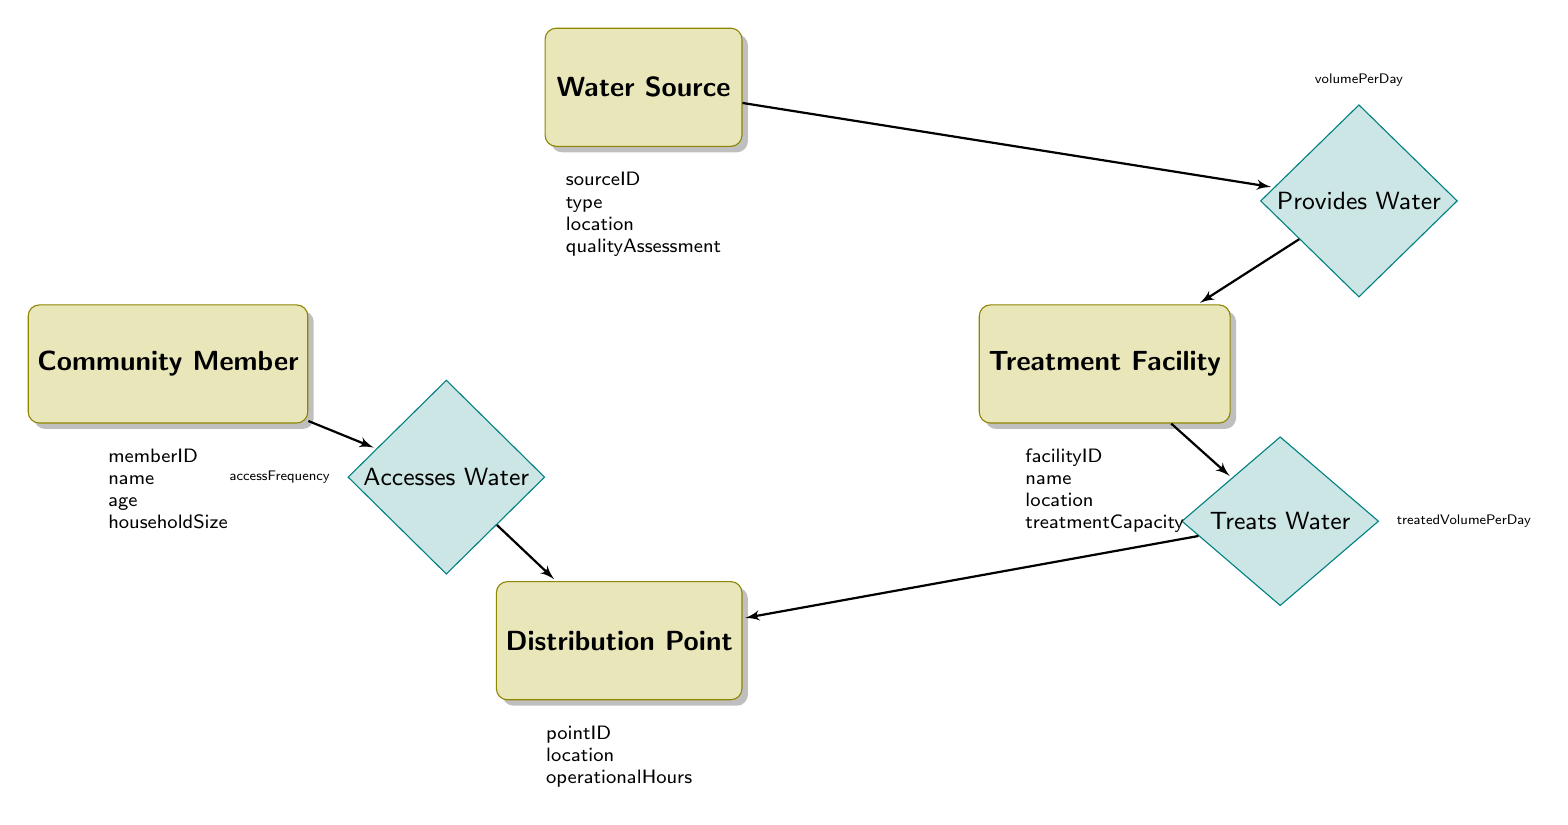What are the attributes of the Water Source entity? The Water Source entity has four attributes listed in the diagram: sourceID, type, location, and qualityAssessment.
Answer: sourceID, type, location, qualityAssessment How many entities are in the diagram? There are four entities in the diagram: Water Source, Treatment Facility, Distribution Point, and Community Member.
Answer: 4 What relationship connects Water Source and Treatment Facility? The relationship that connects Water Source and Treatment Facility is called "Provides Water."
Answer: Provides Water What attribute represents the frequency of water access by Community Members? The attribute that represents the frequency of water access by Community Members is called accessFrequency.
Answer: accessFrequency Which entity is responsible for treating the water that is then distributed? The entity responsible for treating the water is the Treatment Facility.
Answer: Treatment Facility If the Treatment Facility treats 200 units of water per day, what is the relationship attribute for treated water? The relationship attribute for the treated water is treatedVolumePerDay, as specified in the relationship between Treatment Facility and Distribution Point.
Answer: treatedVolumePerDay What is the direct relationship between Community Members and Distribution Points? The direct relationship between Community Members and Distribution Points is called "Accesses Water."
Answer: Accesses Water How does water flow from sources to community members based on the diagram? Water flows from Water Source to Treatment Facility through the "Provides Water" relationship, treating at the facility, then flowing to Distribution Point through the "Treats Water" relationship, allowing Community Members to access it through the "Accesses Water" relationship.
Answer: Water Source → Treatment Facility → Distribution Point → Community Members How many attributes does the Distribution Point entity have? The Distribution Point entity has three attributes: pointID, location, and operationalHours.
Answer: 3 